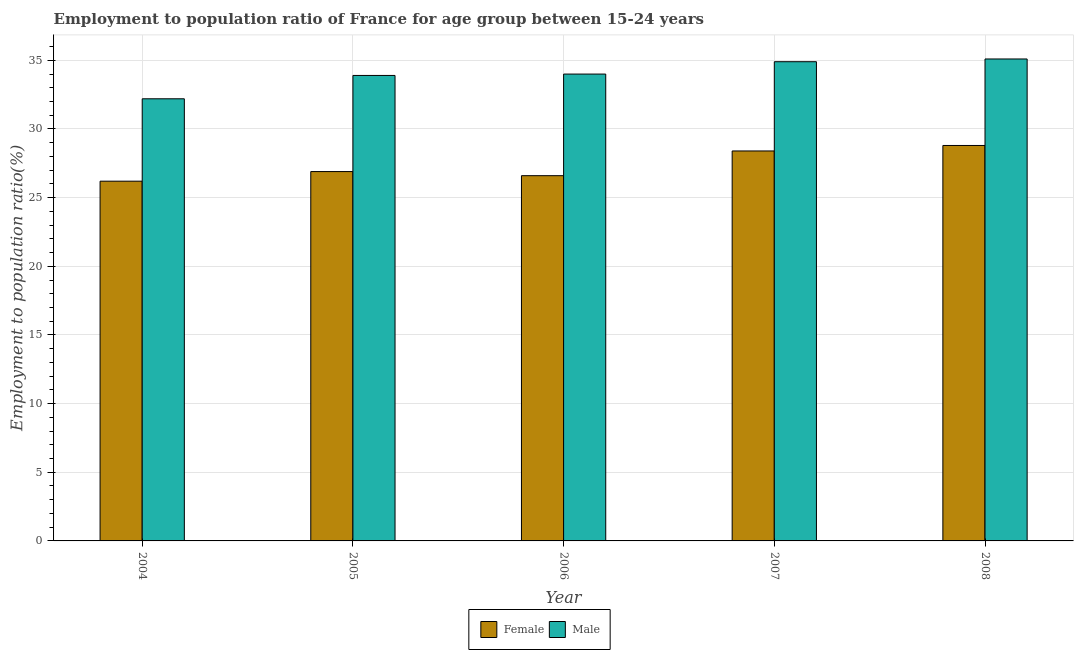How many different coloured bars are there?
Your answer should be compact. 2. How many groups of bars are there?
Provide a succinct answer. 5. Are the number of bars on each tick of the X-axis equal?
Offer a terse response. Yes. How many bars are there on the 3rd tick from the right?
Your answer should be compact. 2. In how many cases, is the number of bars for a given year not equal to the number of legend labels?
Keep it short and to the point. 0. What is the employment to population ratio(male) in 2004?
Give a very brief answer. 32.2. Across all years, what is the maximum employment to population ratio(male)?
Your answer should be compact. 35.1. Across all years, what is the minimum employment to population ratio(female)?
Your response must be concise. 26.2. In which year was the employment to population ratio(male) minimum?
Ensure brevity in your answer.  2004. What is the total employment to population ratio(female) in the graph?
Provide a short and direct response. 136.9. What is the difference between the employment to population ratio(male) in 2007 and that in 2008?
Your answer should be very brief. -0.2. What is the difference between the employment to population ratio(female) in 2005 and the employment to population ratio(male) in 2008?
Your response must be concise. -1.9. What is the average employment to population ratio(male) per year?
Offer a terse response. 34.02. In the year 2008, what is the difference between the employment to population ratio(male) and employment to population ratio(female)?
Your answer should be compact. 0. In how many years, is the employment to population ratio(female) greater than 26 %?
Offer a terse response. 5. What is the ratio of the employment to population ratio(male) in 2006 to that in 2008?
Make the answer very short. 0.97. Is the difference between the employment to population ratio(male) in 2004 and 2006 greater than the difference between the employment to population ratio(female) in 2004 and 2006?
Offer a terse response. No. What is the difference between the highest and the second highest employment to population ratio(female)?
Give a very brief answer. 0.4. What is the difference between the highest and the lowest employment to population ratio(male)?
Keep it short and to the point. 2.9. Is the sum of the employment to population ratio(female) in 2005 and 2007 greater than the maximum employment to population ratio(male) across all years?
Provide a short and direct response. Yes. How many years are there in the graph?
Make the answer very short. 5. Does the graph contain grids?
Your answer should be compact. Yes. Where does the legend appear in the graph?
Your response must be concise. Bottom center. How many legend labels are there?
Your response must be concise. 2. What is the title of the graph?
Give a very brief answer. Employment to population ratio of France for age group between 15-24 years. What is the Employment to population ratio(%) of Female in 2004?
Provide a succinct answer. 26.2. What is the Employment to population ratio(%) of Male in 2004?
Keep it short and to the point. 32.2. What is the Employment to population ratio(%) in Female in 2005?
Provide a succinct answer. 26.9. What is the Employment to population ratio(%) in Male in 2005?
Give a very brief answer. 33.9. What is the Employment to population ratio(%) of Female in 2006?
Make the answer very short. 26.6. What is the Employment to population ratio(%) in Male in 2006?
Offer a very short reply. 34. What is the Employment to population ratio(%) of Female in 2007?
Give a very brief answer. 28.4. What is the Employment to population ratio(%) in Male in 2007?
Provide a short and direct response. 34.9. What is the Employment to population ratio(%) of Female in 2008?
Make the answer very short. 28.8. What is the Employment to population ratio(%) of Male in 2008?
Your answer should be very brief. 35.1. Across all years, what is the maximum Employment to population ratio(%) of Female?
Offer a very short reply. 28.8. Across all years, what is the maximum Employment to population ratio(%) in Male?
Your answer should be compact. 35.1. Across all years, what is the minimum Employment to population ratio(%) of Female?
Provide a short and direct response. 26.2. Across all years, what is the minimum Employment to population ratio(%) in Male?
Make the answer very short. 32.2. What is the total Employment to population ratio(%) in Female in the graph?
Make the answer very short. 136.9. What is the total Employment to population ratio(%) of Male in the graph?
Make the answer very short. 170.1. What is the difference between the Employment to population ratio(%) in Female in 2004 and that in 2005?
Your answer should be very brief. -0.7. What is the difference between the Employment to population ratio(%) in Female in 2004 and that in 2006?
Provide a succinct answer. -0.4. What is the difference between the Employment to population ratio(%) in Female in 2004 and that in 2008?
Provide a short and direct response. -2.6. What is the difference between the Employment to population ratio(%) of Male in 2004 and that in 2008?
Ensure brevity in your answer.  -2.9. What is the difference between the Employment to population ratio(%) of Female in 2005 and that in 2006?
Your response must be concise. 0.3. What is the difference between the Employment to population ratio(%) in Male in 2005 and that in 2006?
Offer a very short reply. -0.1. What is the difference between the Employment to population ratio(%) of Female in 2005 and that in 2007?
Provide a succinct answer. -1.5. What is the difference between the Employment to population ratio(%) in Female in 2005 and that in 2008?
Provide a succinct answer. -1.9. What is the difference between the Employment to population ratio(%) of Male in 2005 and that in 2008?
Ensure brevity in your answer.  -1.2. What is the difference between the Employment to population ratio(%) in Female in 2006 and that in 2007?
Provide a short and direct response. -1.8. What is the difference between the Employment to population ratio(%) of Female in 2006 and that in 2008?
Ensure brevity in your answer.  -2.2. What is the difference between the Employment to population ratio(%) of Female in 2004 and the Employment to population ratio(%) of Male in 2005?
Your answer should be compact. -7.7. What is the difference between the Employment to population ratio(%) of Female in 2004 and the Employment to population ratio(%) of Male in 2006?
Provide a succinct answer. -7.8. What is the difference between the Employment to population ratio(%) of Female in 2004 and the Employment to population ratio(%) of Male in 2007?
Your response must be concise. -8.7. What is the difference between the Employment to population ratio(%) of Female in 2004 and the Employment to population ratio(%) of Male in 2008?
Your answer should be compact. -8.9. What is the difference between the Employment to population ratio(%) of Female in 2005 and the Employment to population ratio(%) of Male in 2006?
Give a very brief answer. -7.1. What is the difference between the Employment to population ratio(%) of Female in 2005 and the Employment to population ratio(%) of Male in 2007?
Your response must be concise. -8. What is the difference between the Employment to population ratio(%) in Female in 2006 and the Employment to population ratio(%) in Male in 2007?
Offer a terse response. -8.3. What is the difference between the Employment to population ratio(%) of Female in 2006 and the Employment to population ratio(%) of Male in 2008?
Offer a terse response. -8.5. What is the average Employment to population ratio(%) of Female per year?
Your answer should be very brief. 27.38. What is the average Employment to population ratio(%) of Male per year?
Provide a succinct answer. 34.02. In the year 2004, what is the difference between the Employment to population ratio(%) of Female and Employment to population ratio(%) of Male?
Offer a very short reply. -6. In the year 2005, what is the difference between the Employment to population ratio(%) in Female and Employment to population ratio(%) in Male?
Offer a terse response. -7. In the year 2006, what is the difference between the Employment to population ratio(%) in Female and Employment to population ratio(%) in Male?
Make the answer very short. -7.4. What is the ratio of the Employment to population ratio(%) of Male in 2004 to that in 2005?
Provide a short and direct response. 0.95. What is the ratio of the Employment to population ratio(%) in Female in 2004 to that in 2006?
Give a very brief answer. 0.98. What is the ratio of the Employment to population ratio(%) in Male in 2004 to that in 2006?
Offer a very short reply. 0.95. What is the ratio of the Employment to population ratio(%) in Female in 2004 to that in 2007?
Your response must be concise. 0.92. What is the ratio of the Employment to population ratio(%) in Male in 2004 to that in 2007?
Your answer should be compact. 0.92. What is the ratio of the Employment to population ratio(%) in Female in 2004 to that in 2008?
Your answer should be very brief. 0.91. What is the ratio of the Employment to population ratio(%) of Male in 2004 to that in 2008?
Your answer should be very brief. 0.92. What is the ratio of the Employment to population ratio(%) in Female in 2005 to that in 2006?
Provide a succinct answer. 1.01. What is the ratio of the Employment to population ratio(%) in Male in 2005 to that in 2006?
Your response must be concise. 1. What is the ratio of the Employment to population ratio(%) in Female in 2005 to that in 2007?
Your answer should be very brief. 0.95. What is the ratio of the Employment to population ratio(%) of Male in 2005 to that in 2007?
Offer a very short reply. 0.97. What is the ratio of the Employment to population ratio(%) of Female in 2005 to that in 2008?
Make the answer very short. 0.93. What is the ratio of the Employment to population ratio(%) of Male in 2005 to that in 2008?
Ensure brevity in your answer.  0.97. What is the ratio of the Employment to population ratio(%) in Female in 2006 to that in 2007?
Your response must be concise. 0.94. What is the ratio of the Employment to population ratio(%) of Male in 2006 to that in 2007?
Give a very brief answer. 0.97. What is the ratio of the Employment to population ratio(%) in Female in 2006 to that in 2008?
Give a very brief answer. 0.92. What is the ratio of the Employment to population ratio(%) in Male in 2006 to that in 2008?
Keep it short and to the point. 0.97. What is the ratio of the Employment to population ratio(%) of Female in 2007 to that in 2008?
Your response must be concise. 0.99. What is the difference between the highest and the second highest Employment to population ratio(%) of Female?
Provide a succinct answer. 0.4. What is the difference between the highest and the second highest Employment to population ratio(%) in Male?
Provide a short and direct response. 0.2. What is the difference between the highest and the lowest Employment to population ratio(%) in Female?
Provide a succinct answer. 2.6. What is the difference between the highest and the lowest Employment to population ratio(%) of Male?
Ensure brevity in your answer.  2.9. 